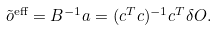Convert formula to latex. <formula><loc_0><loc_0><loc_500><loc_500>\tilde { o } ^ { \text {eff} } = B ^ { - 1 } a = ( c ^ { T } c ) ^ { - 1 } c ^ { T } \delta O .</formula> 